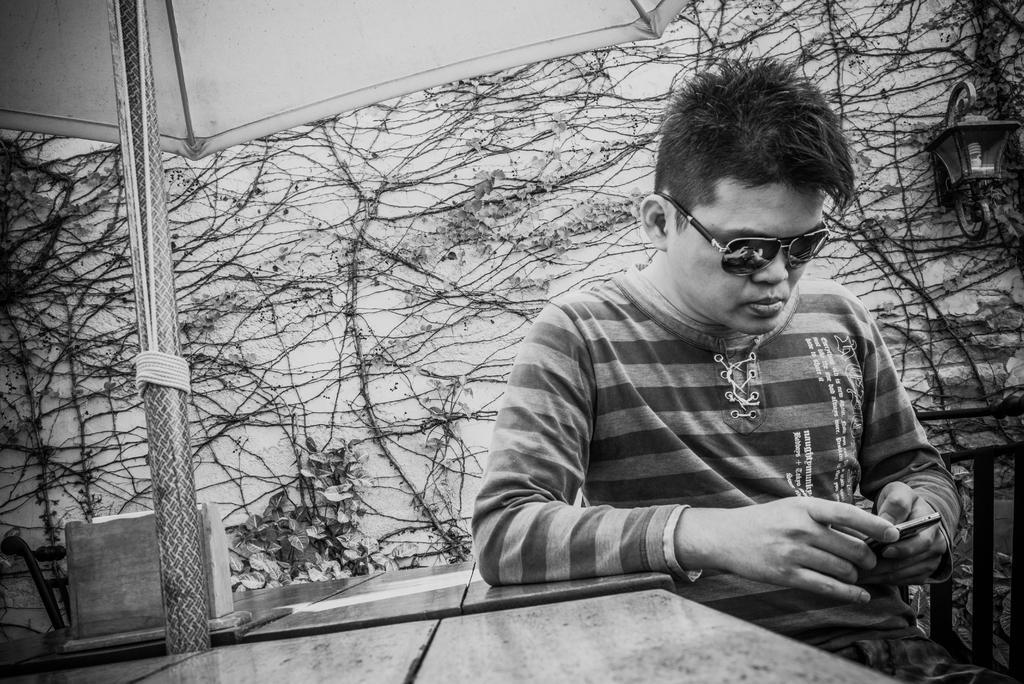In one or two sentences, can you explain what this image depicts? In this black and white image there is a person sitting on the chair and he is using his mobile, beside him there is an object on the table, above the table there is a canopy. In the background there are plants on the wall. On the other side of the image there is a railing. 